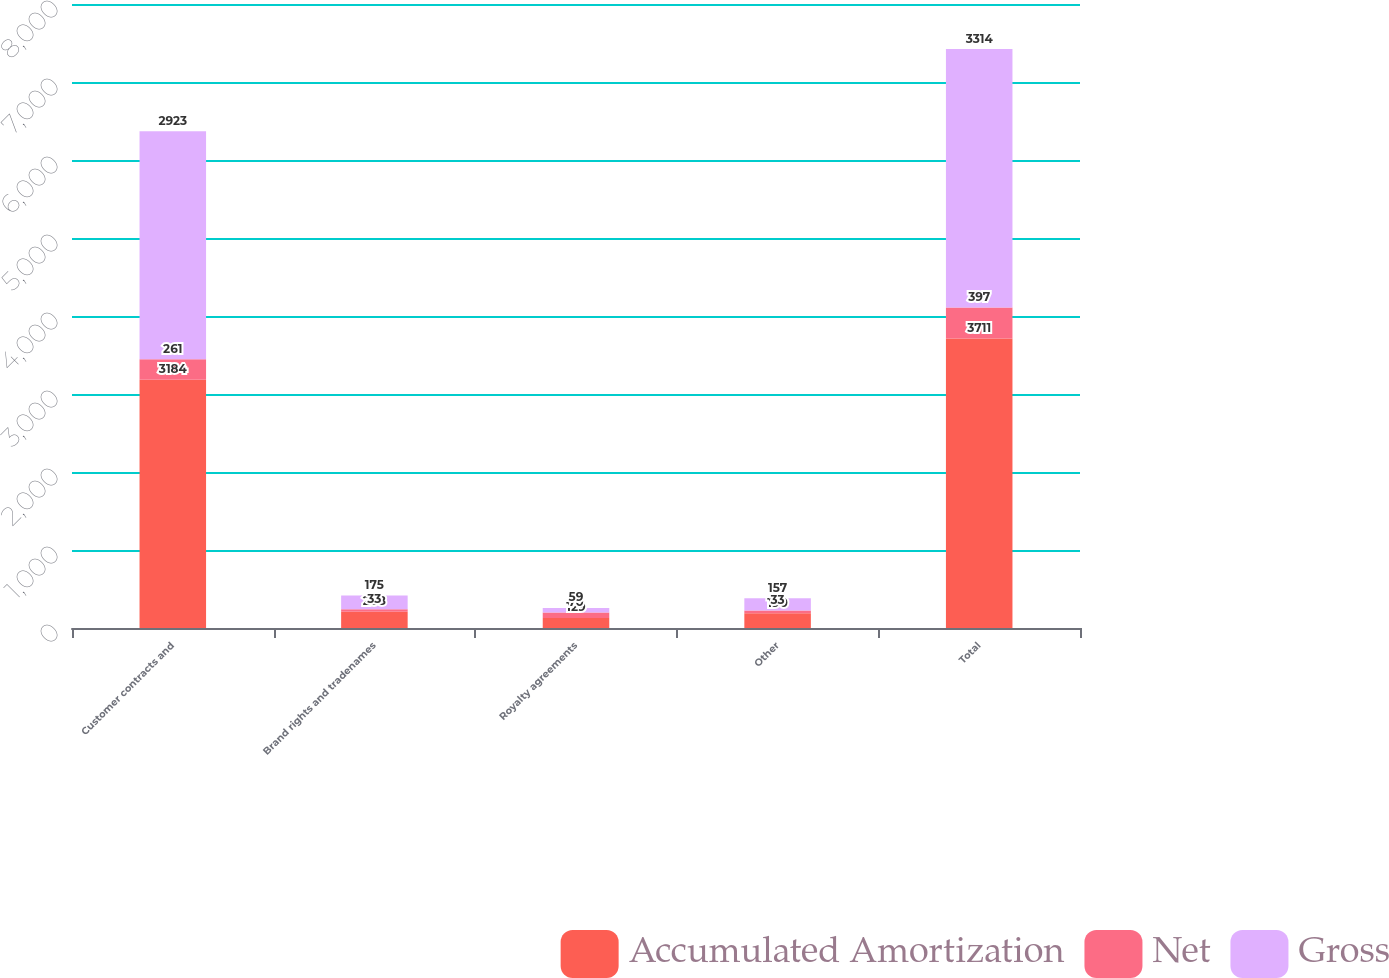Convert chart to OTSL. <chart><loc_0><loc_0><loc_500><loc_500><stacked_bar_chart><ecel><fcel>Customer contracts and<fcel>Brand rights and tradenames<fcel>Royalty agreements<fcel>Other<fcel>Total<nl><fcel>Accumulated Amortization<fcel>3184<fcel>208<fcel>129<fcel>190<fcel>3711<nl><fcel>Net<fcel>261<fcel>33<fcel>70<fcel>33<fcel>397<nl><fcel>Gross<fcel>2923<fcel>175<fcel>59<fcel>157<fcel>3314<nl></chart> 